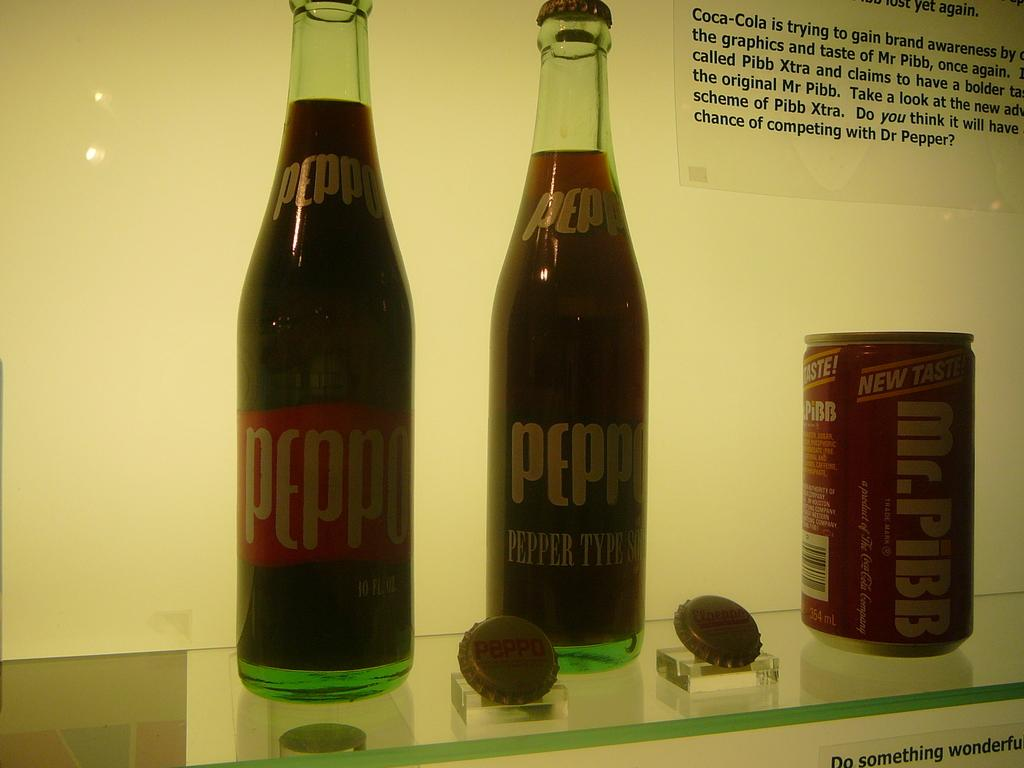How many containers are visible in the image? There are two bottles and one can in the image, making a total of three containers. What is the label on the can? The can is labeled "New Taste". What can be seen in the background of the image? There is a wall in the background of the image. What type of dinner is being served in the image? There is no dinner present in the image; it only features two bottles and a can. How does the mailbox in the image express disgust? There is no mailbox present in the image, and therefore it cannot express any emotion. 